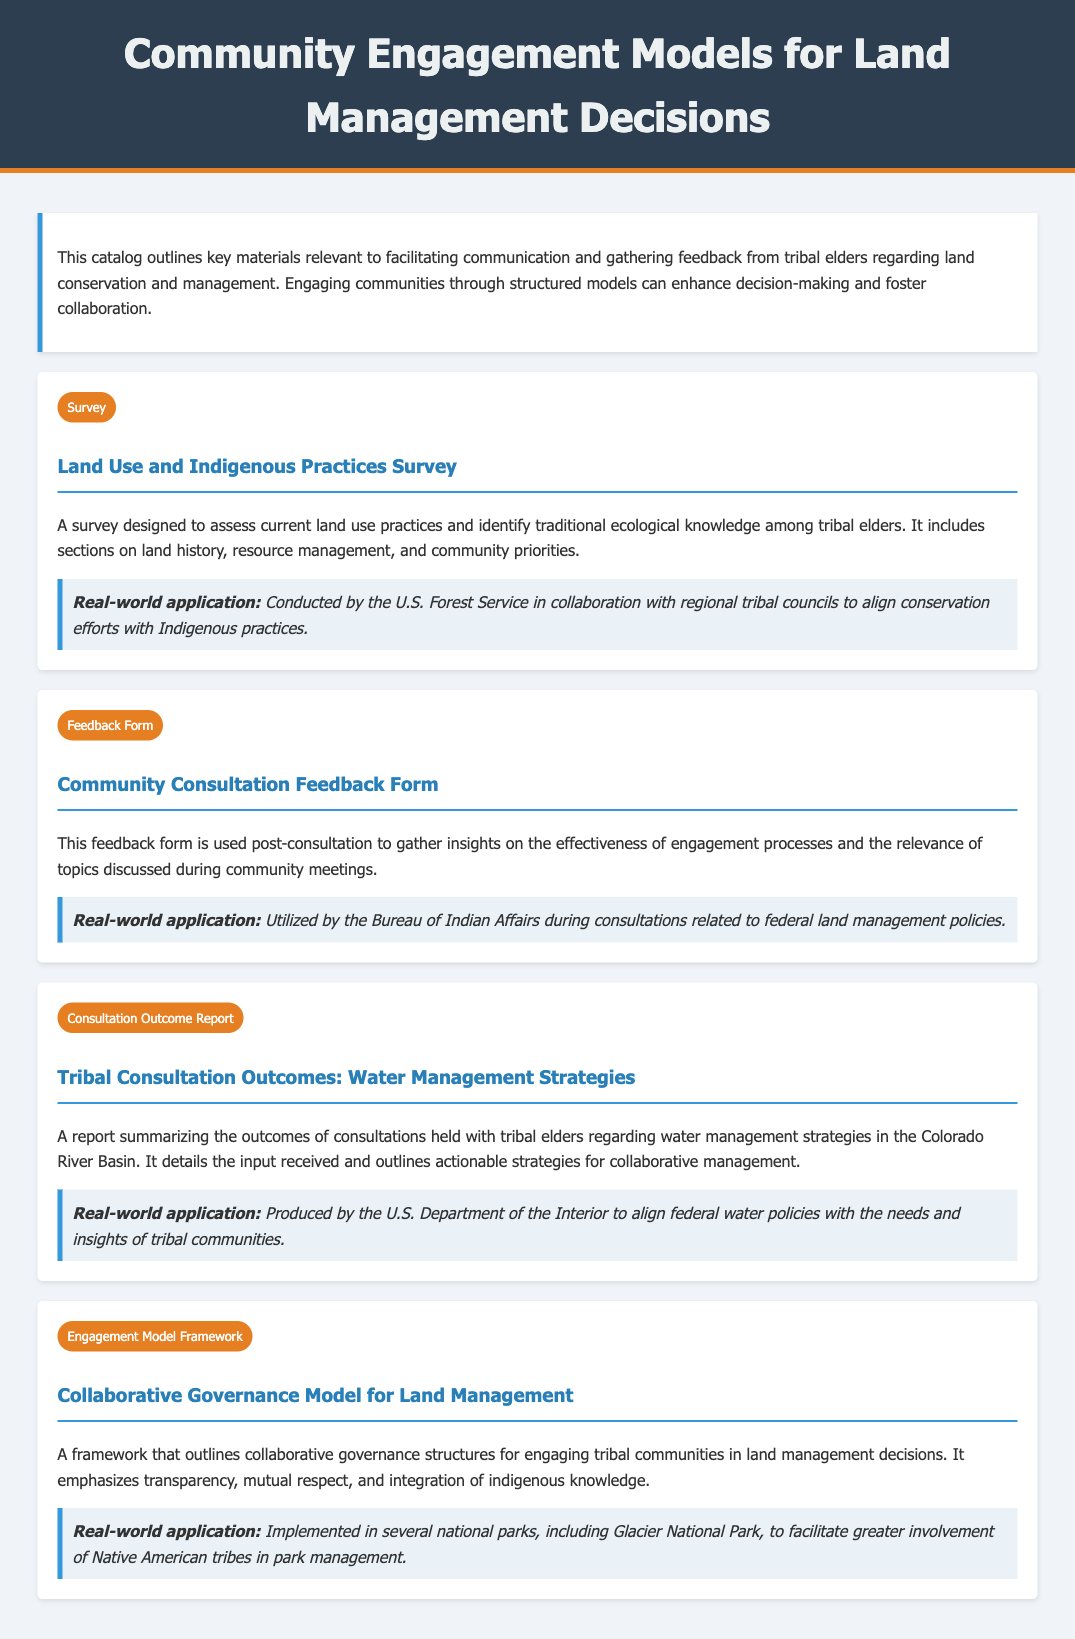what is the title of the document? The title is specified in the header section of the document.
Answer: Community Engagement Models for Land Management Decisions how many materials are listed in the document? The number of materials can be determined by counting the distinct material sections in the document.
Answer: 4 what type of survey is included in the document? The type of survey is described in the material section under the Survey category.
Answer: Land Use and Indigenous Practices Survey what is the purpose of the Community Consultation Feedback Form? The purpose of the feedback form is explained in its description within the document.
Answer: To gather insights on the effectiveness of engagement processes which government agency conducted the survey in collaboration with tribal councils? The agency involved in this collaboration is mentioned in the application section of the survey material.
Answer: U.S. Forest Service what framework is discussed for engaging tribal communities? The specific framework is identified in the Engagement Model Framework material.
Answer: Collaborative Governance Model for Land Management which national park is mentioned as implementing the collaborative model? The park implementing the model is referenced in the application section of the engagement framework.
Answer: Glacier National Park what is the main focus of the Tribal Consultation Outcomes report? The main focus is outlined in the description of the consultation outcome report.
Answer: Water Management Strategies 